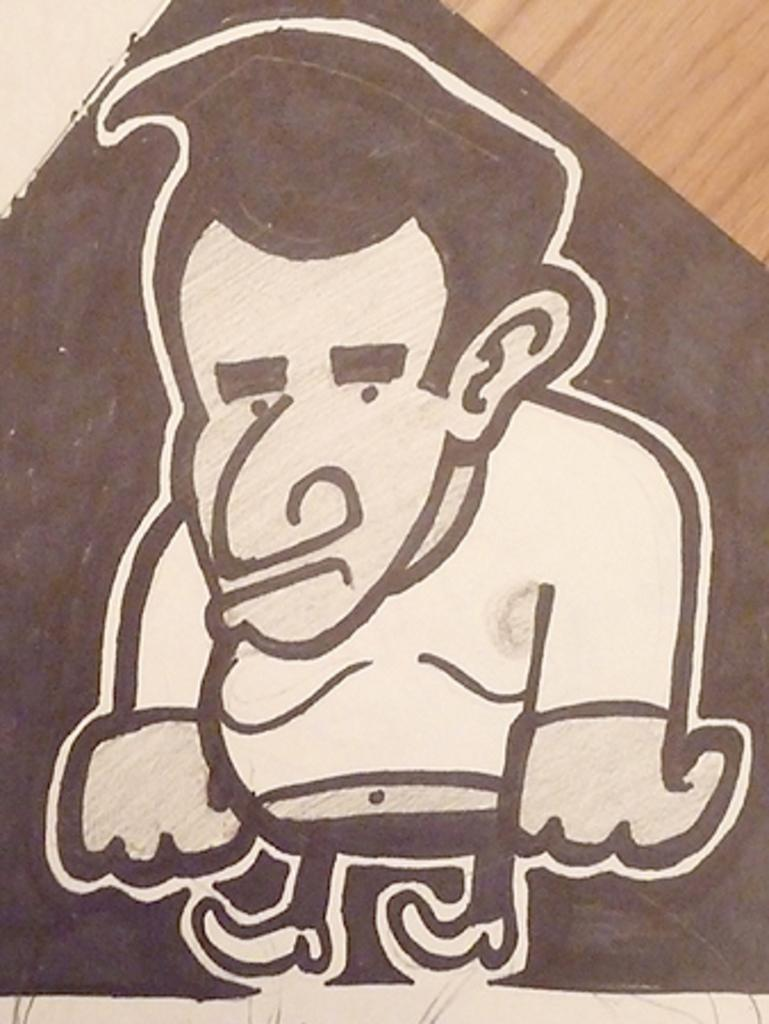What is the main subject of the image? There is a painting in the image. What does the painting depict? The painting depicts a person. What flavor of worm can be seen in the painting? There are no worms present in the painting; it depicts a person. 